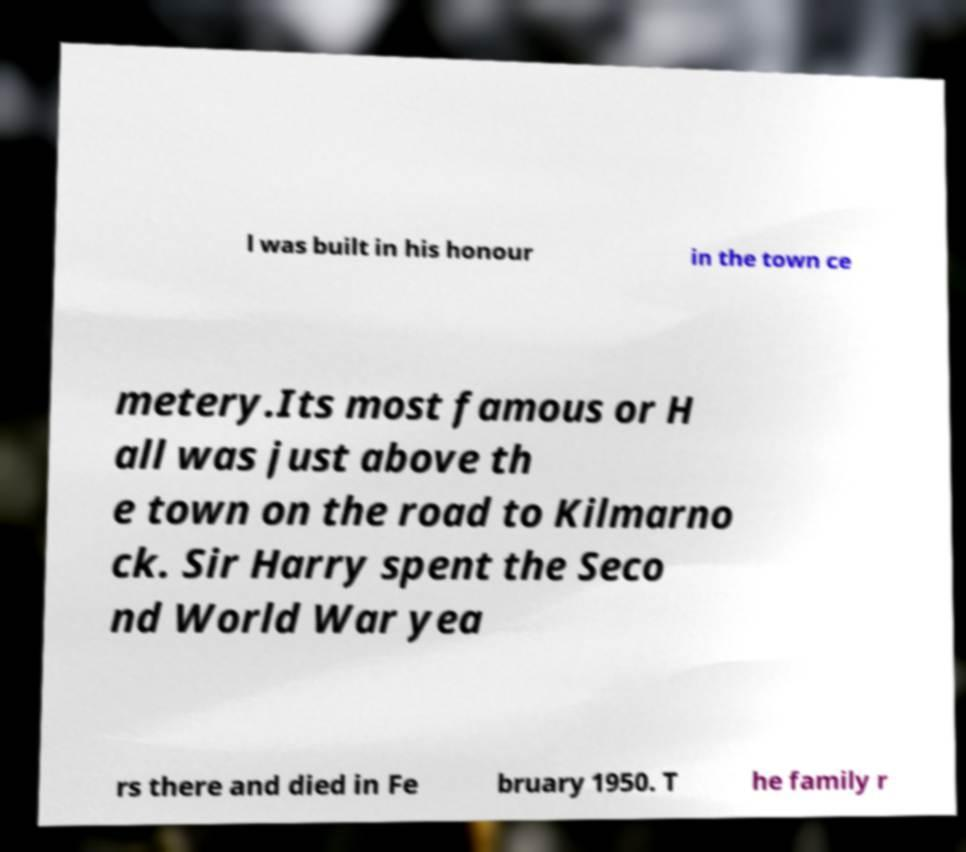I need the written content from this picture converted into text. Can you do that? l was built in his honour in the town ce metery.Its most famous or H all was just above th e town on the road to Kilmarno ck. Sir Harry spent the Seco nd World War yea rs there and died in Fe bruary 1950. T he family r 